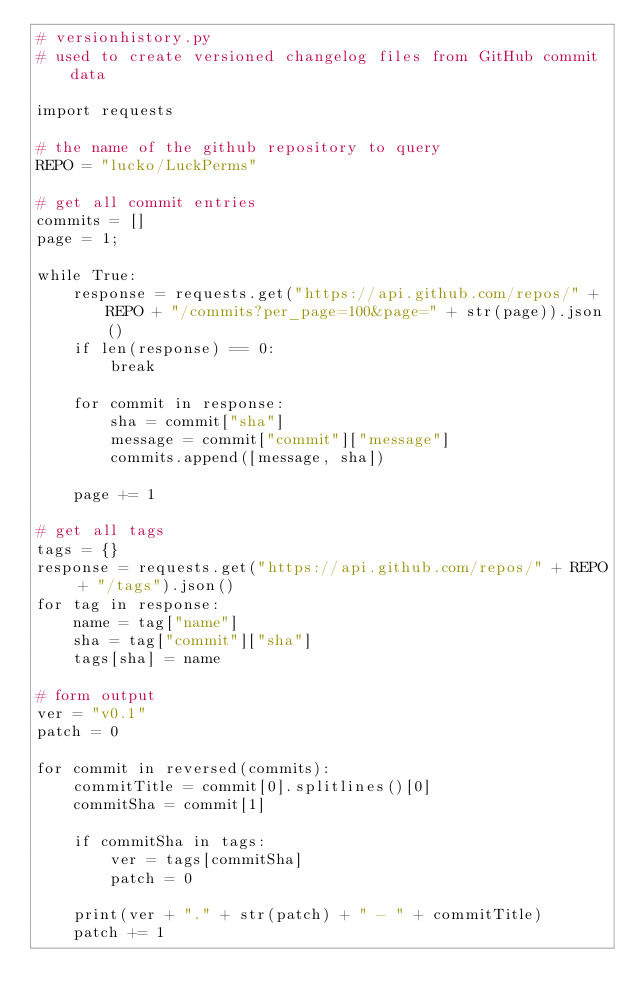Convert code to text. <code><loc_0><loc_0><loc_500><loc_500><_Python_># versionhistory.py
# used to create versioned changelog files from GitHub commit data

import requests

# the name of the github repository to query
REPO = "lucko/LuckPerms"

# get all commit entries
commits = []
page = 1;

while True:
    response = requests.get("https://api.github.com/repos/" + REPO + "/commits?per_page=100&page=" + str(page)).json()
    if len(response) == 0:
        break

    for commit in response:
        sha = commit["sha"]
        message = commit["commit"]["message"]
        commits.append([message, sha])

    page += 1

# get all tags
tags = {}
response = requests.get("https://api.github.com/repos/" + REPO + "/tags").json()
for tag in response:
    name = tag["name"]
    sha = tag["commit"]["sha"]
    tags[sha] = name

# form output
ver = "v0.1"
patch = 0

for commit in reversed(commits):
    commitTitle = commit[0].splitlines()[0]
    commitSha = commit[1]

    if commitSha in tags:
        ver = tags[commitSha]
        patch = 0
    
    print(ver + "." + str(patch) + " - " + commitTitle)
    patch += 1
</code> 